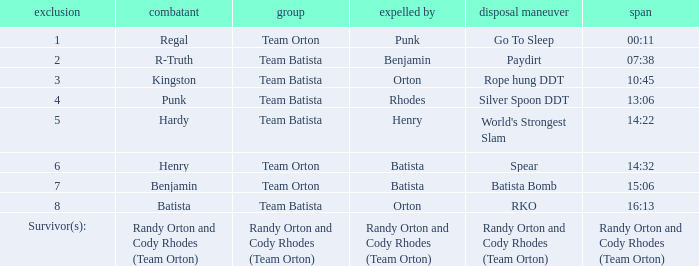At what time did batista eliminate wrestler henry? 14:32. 